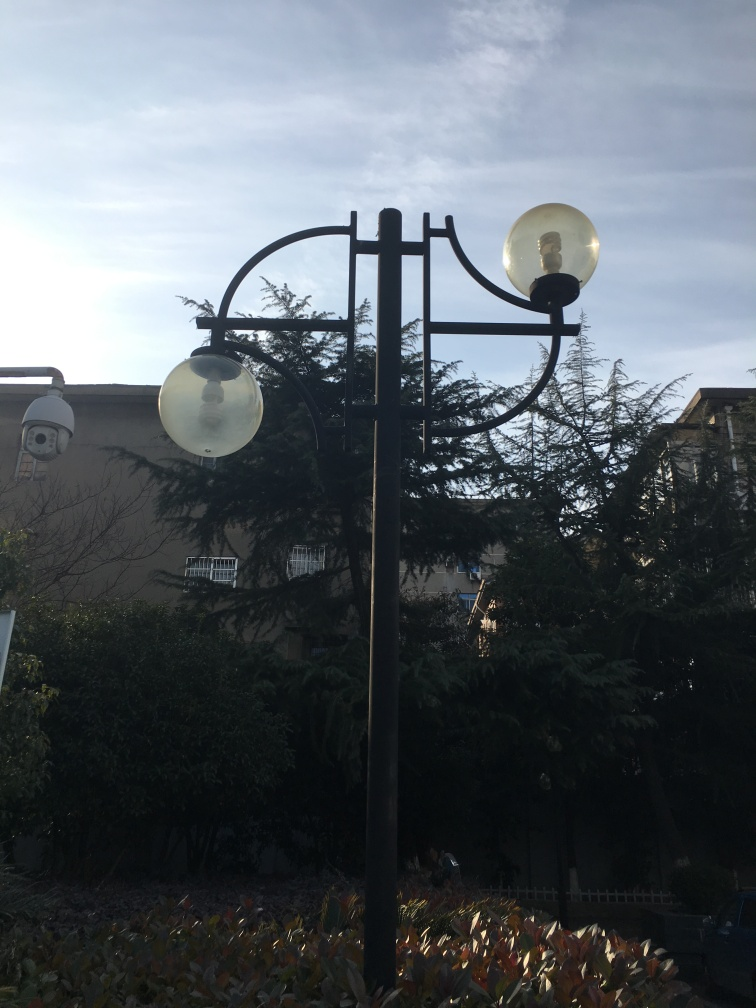Can you describe the weather conditions in the image? The weather in the image appears to be clear with no visible signs of precipitation. The sky is bright, indicating that the sun might be behind the clouds or just out of frame, which along with the shadows and visibility in the scene, suggests fair weather conditions. 